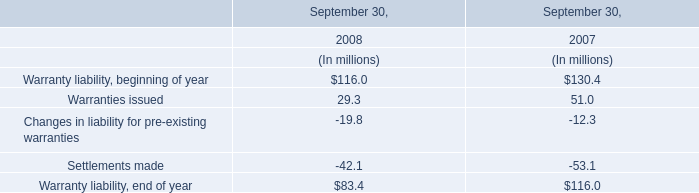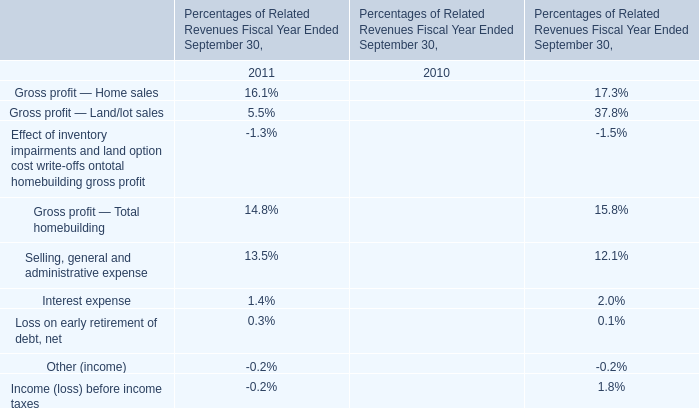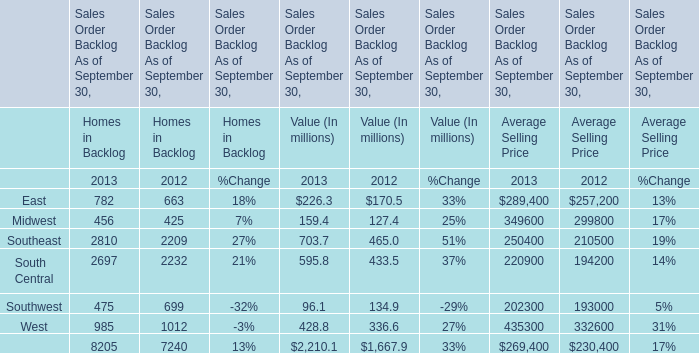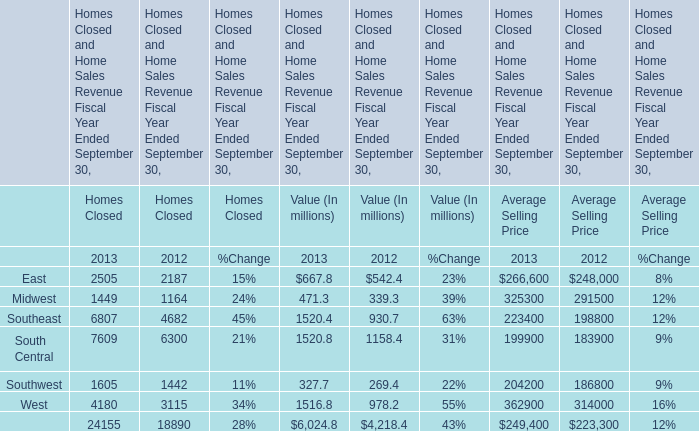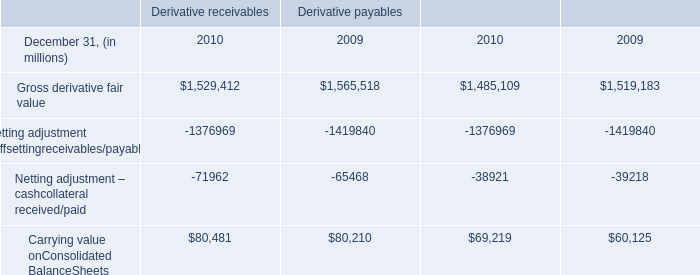What is the average growth rate of East for Homes in Backlog between 2012 and 2013? 
Computations: ((782 - 663) / 663)
Answer: 0.17949. 